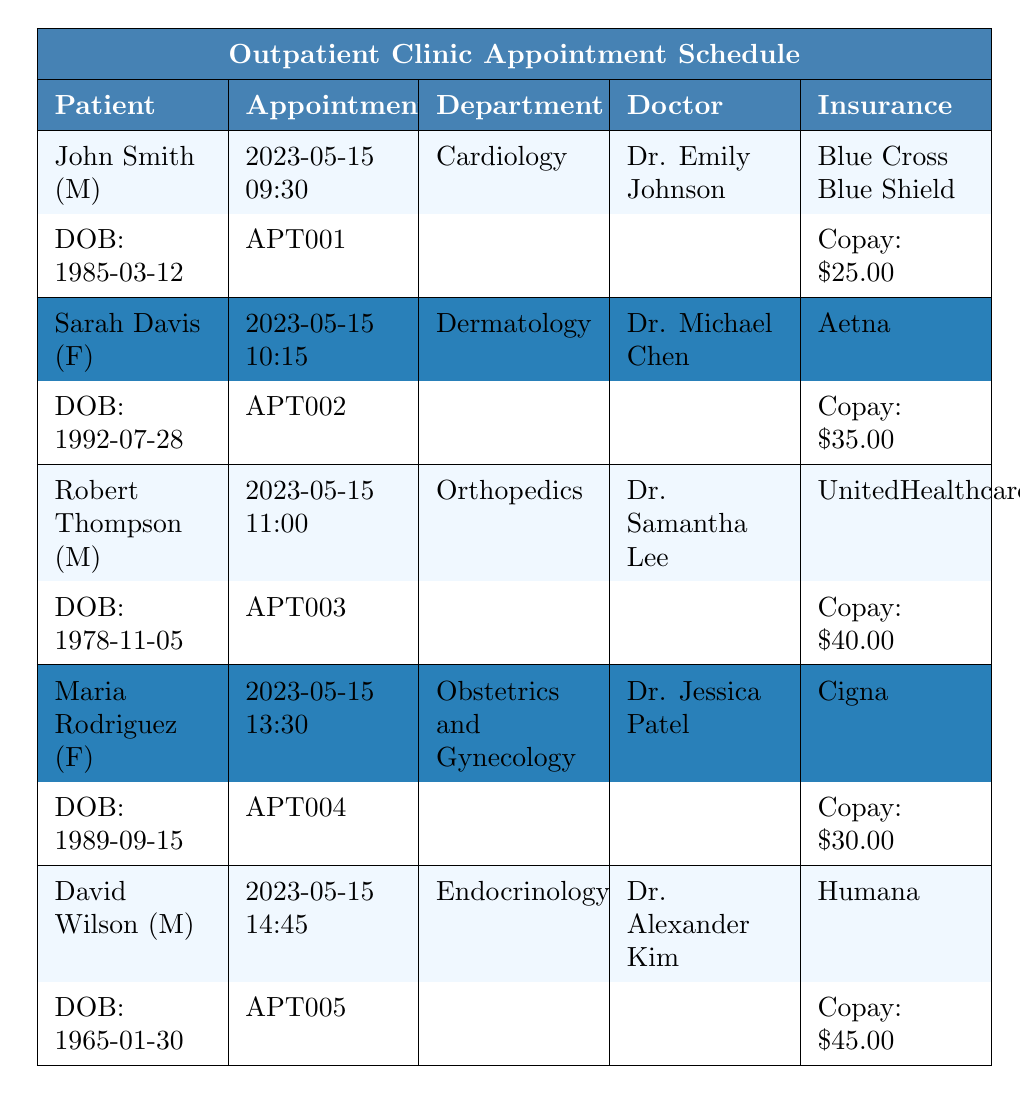What is the appointment date for John Smith? The appointment date for John Smith is listed under his entry in the table, which shows 2023-05-15.
Answer: 2023-05-15 Who is the doctor for Sarah Davis's appointment? The doctor's name for Sarah Davis's appointment is provided in her row of the table, which states Dr. Michael Chen.
Answer: Dr. Michael Chen What is the copay amount for Robert Thompson? The copay amount for Robert Thompson can be found in his appointment details, which indicates it is $40.00.
Answer: $40.00 Is there an appointment for a gentleman in the Dermatology department? Looking at the table, Sarah Davis's appointment is in the Dermatology department and she is female. There are no male patients listed for Dermatology.
Answer: No How many appointments are scheduled on 2023-05-15? There are five appointments listed in the table, all scheduled for the same date, which is 2023-05-15.
Answer: 5 What is the total copay amount of all appointments? Adding up the copay amounts from the table: 25 + 35 + 40 + 30 + 45 = 175. Therefore, the total copay amount is $175.
Answer: $175 Which department has the highest copay amount scheduled? Robert Thompson in Orthopedics has the highest copay amount at $40 among the listed appointments.
Answer: Orthopedics Which patient has a visit reason related to diabetes management? By reviewing the entries, David Wilson's reason for visit is explicitly stated as diabetes management.
Answer: David Wilson How many female patients are listed in this appointment schedule? The entries for Sarah Davis and Maria Rodriguez identify both as female, resulting in a count of two female patients.
Answer: 2 What is the age of Maria Rodriguez on her appointment date? Maria Rodriguez's date of birth is 1989-09-15. To calculate her age on 2023-05-15, subtract the year of birth from the appointment year: 2023 - 1989 = 34. This indicates she is 34 years old.
Answer: 34 